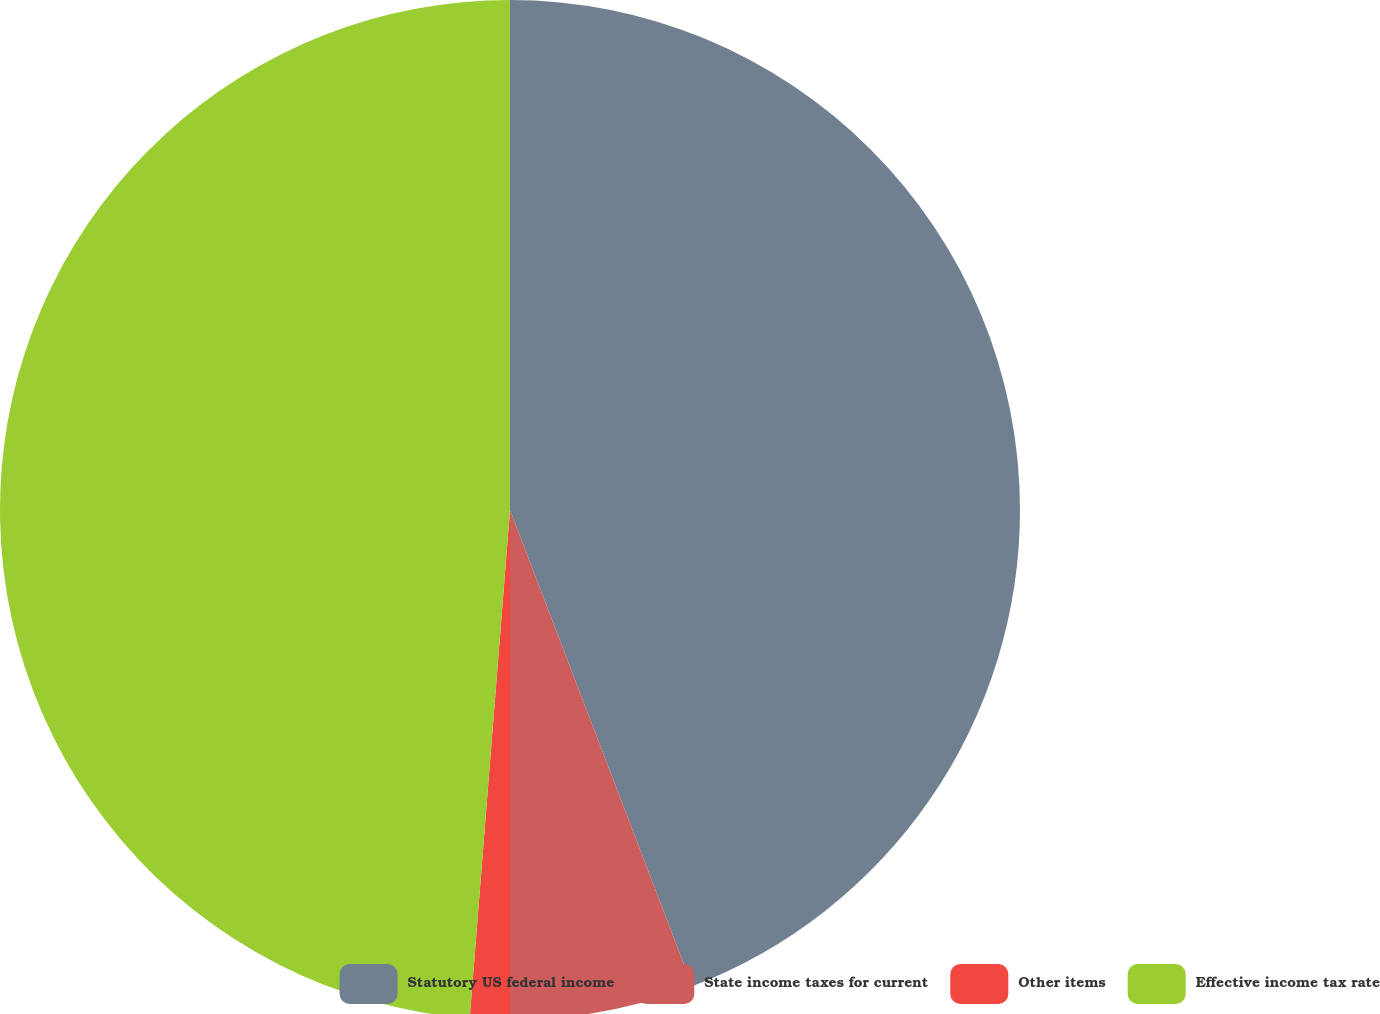<chart> <loc_0><loc_0><loc_500><loc_500><pie_chart><fcel>Statutory US federal income<fcel>State income taxes for current<fcel>Other items<fcel>Effective income tax rate<nl><fcel>44.18%<fcel>5.82%<fcel>1.26%<fcel>48.74%<nl></chart> 